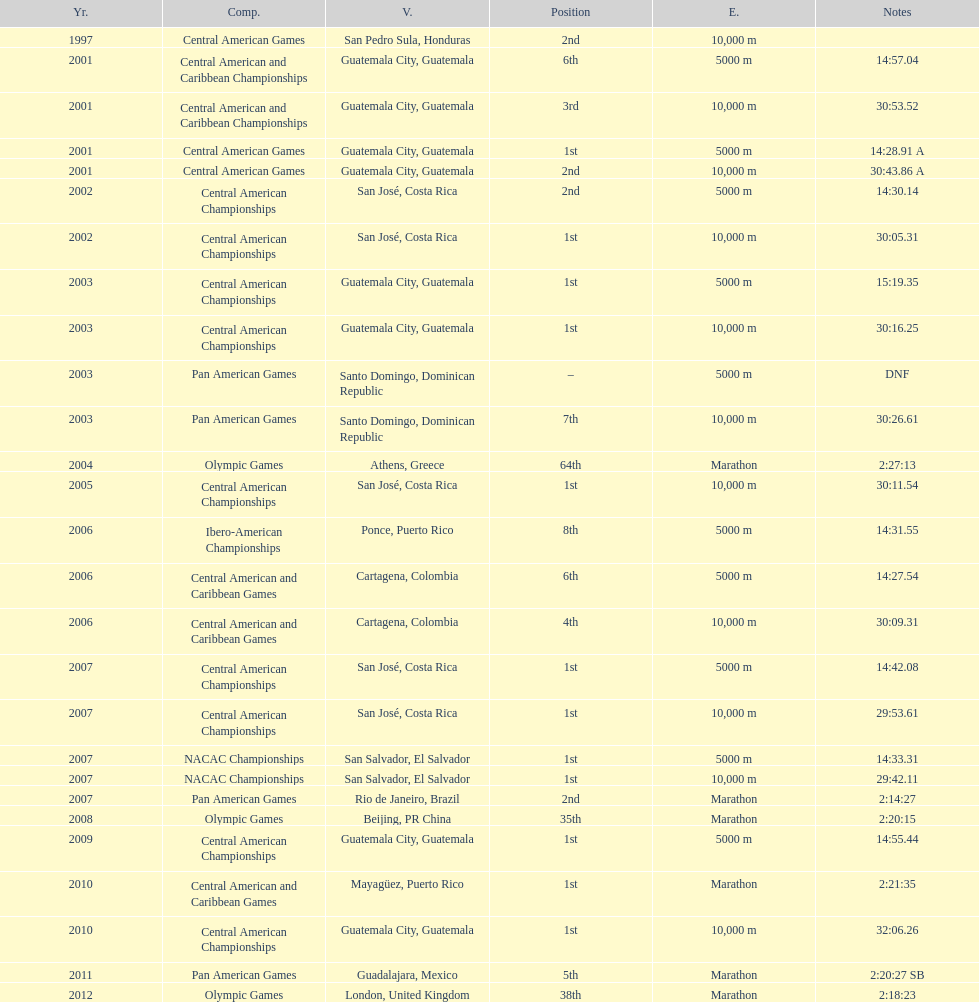In the final contest, when was a "2nd" place position accomplished? Pan American Games. 